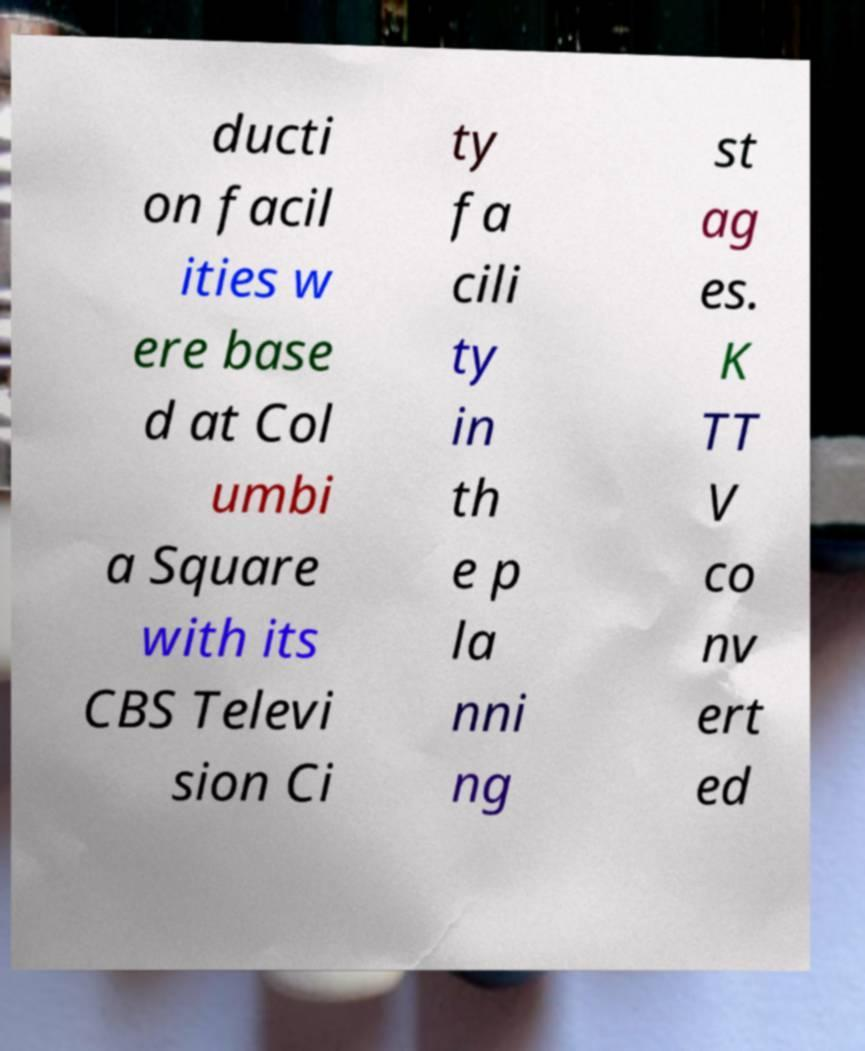For documentation purposes, I need the text within this image transcribed. Could you provide that? ducti on facil ities w ere base d at Col umbi a Square with its CBS Televi sion Ci ty fa cili ty in th e p la nni ng st ag es. K TT V co nv ert ed 